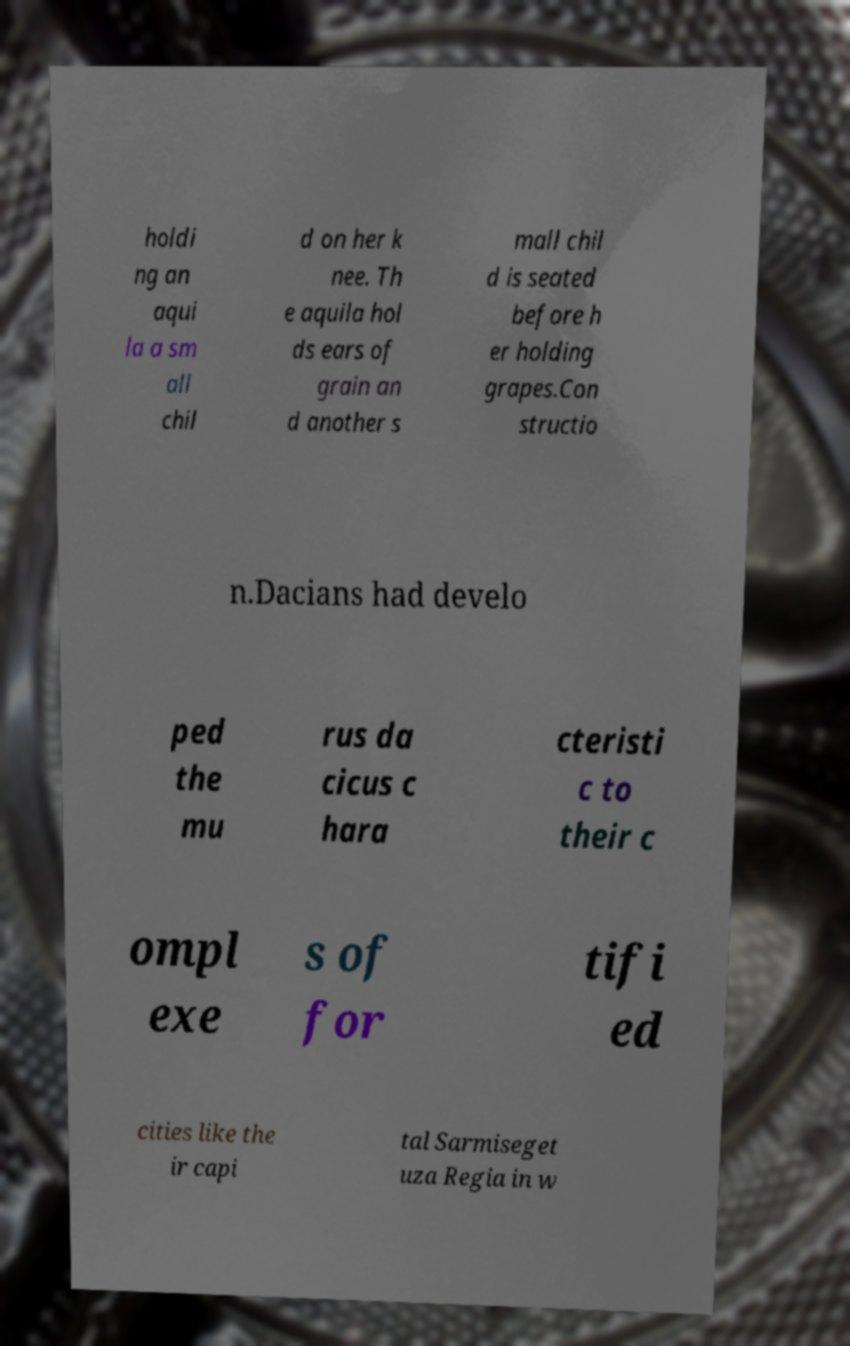For documentation purposes, I need the text within this image transcribed. Could you provide that? holdi ng an aqui la a sm all chil d on her k nee. Th e aquila hol ds ears of grain an d another s mall chil d is seated before h er holding grapes.Con structio n.Dacians had develo ped the mu rus da cicus c hara cteristi c to their c ompl exe s of for tifi ed cities like the ir capi tal Sarmiseget uza Regia in w 